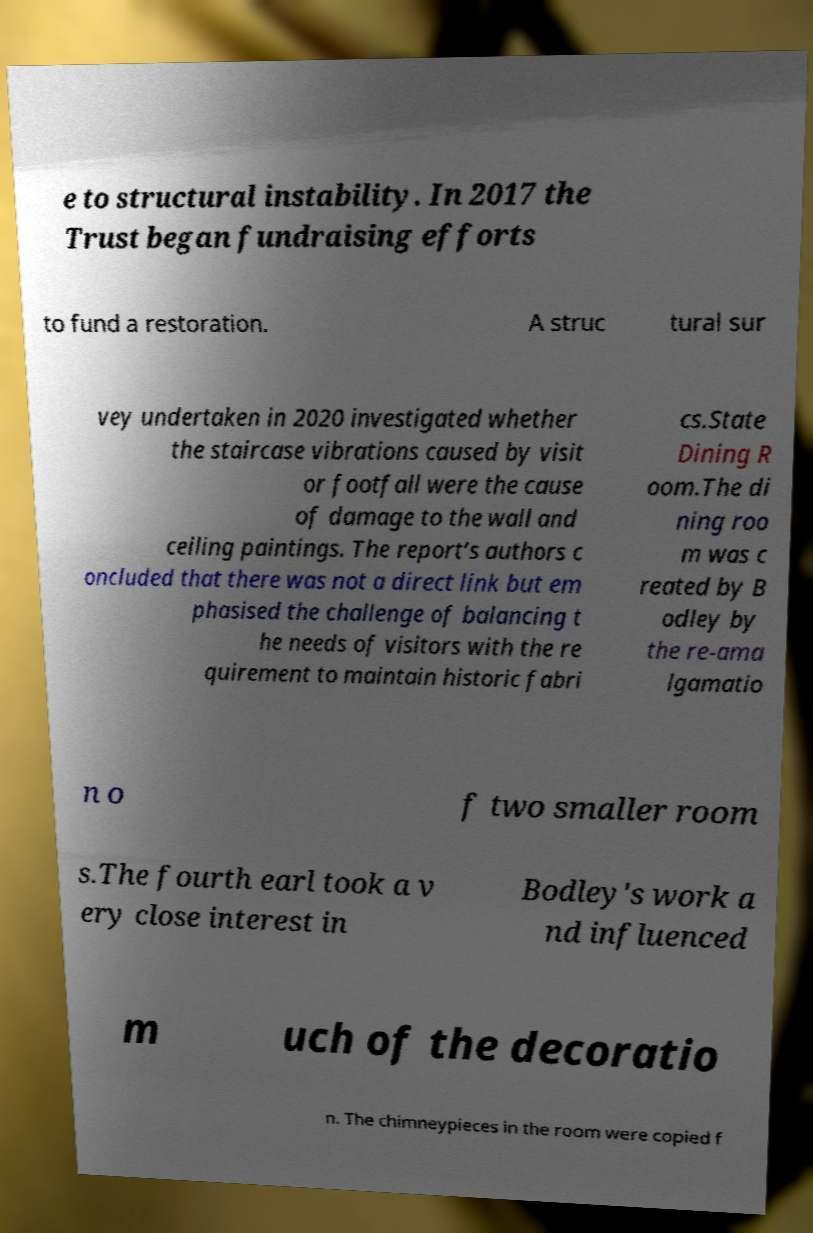Could you assist in decoding the text presented in this image and type it out clearly? e to structural instability. In 2017 the Trust began fundraising efforts to fund a restoration. A struc tural sur vey undertaken in 2020 investigated whether the staircase vibrations caused by visit or footfall were the cause of damage to the wall and ceiling paintings. The report’s authors c oncluded that there was not a direct link but em phasised the challenge of balancing t he needs of visitors with the re quirement to maintain historic fabri cs.State Dining R oom.The di ning roo m was c reated by B odley by the re-ama lgamatio n o f two smaller room s.The fourth earl took a v ery close interest in Bodley's work a nd influenced m uch of the decoratio n. The chimneypieces in the room were copied f 